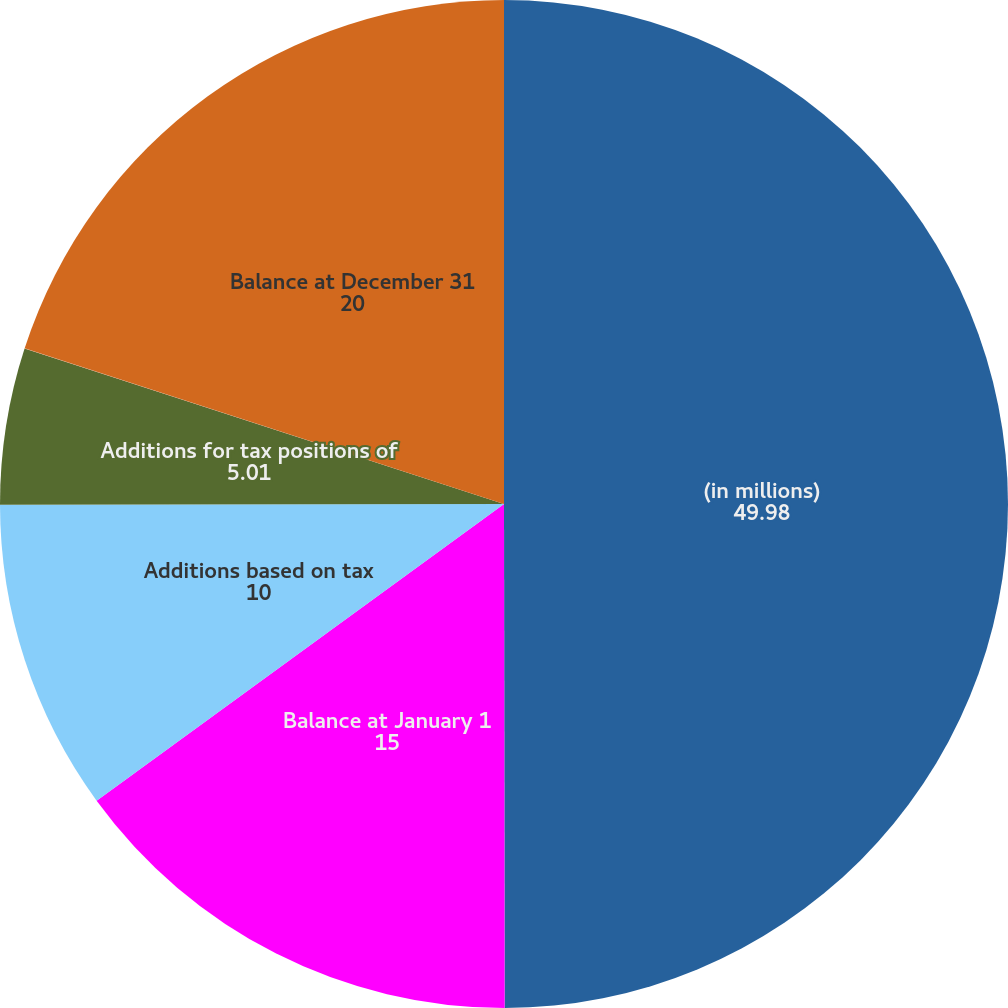Convert chart to OTSL. <chart><loc_0><loc_0><loc_500><loc_500><pie_chart><fcel>(in millions)<fcel>Balance at January 1<fcel>Additions based on tax<fcel>Additions for tax positions of<fcel>Reductions for tax positions<fcel>Balance at December 31<nl><fcel>49.98%<fcel>15.0%<fcel>10.0%<fcel>5.01%<fcel>0.01%<fcel>20.0%<nl></chart> 